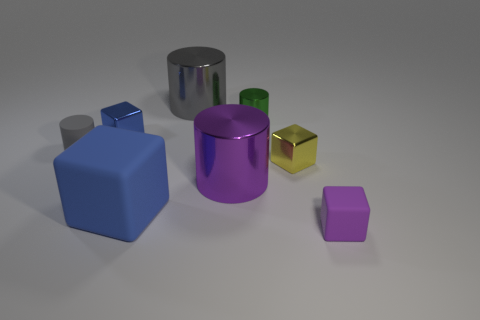There is a small object that is the same color as the large rubber object; what is it made of?
Your response must be concise. Metal. How big is the cylinder that is both in front of the blue metal cube and behind the tiny yellow cube?
Give a very brief answer. Small. How many blue objects are small rubber cylinders or metal cylinders?
Your response must be concise. 0. There is a gray rubber thing that is the same size as the green cylinder; what shape is it?
Offer a very short reply. Cylinder. What number of other objects are there of the same color as the small metallic cylinder?
Your answer should be compact. 0. How big is the shiny block behind the small cylinder in front of the tiny green cylinder?
Your answer should be very brief. Small. Do the blue thing that is behind the matte cylinder and the big purple object have the same material?
Your answer should be compact. Yes. The gray object right of the big blue matte thing has what shape?
Your answer should be very brief. Cylinder. How many yellow metal objects have the same size as the green cylinder?
Your answer should be very brief. 1. The gray rubber cylinder has what size?
Give a very brief answer. Small. 